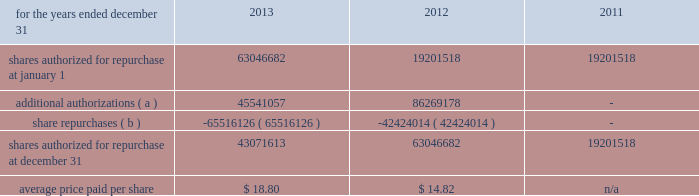Management 2019s discussion and analysis of financial condition and results of operations 82 fifth third bancorp to 100 million shares of its outstanding common stock in the open market or in privately negotiated transactions , and to utilize any derivative or similar instrument to affect share repurchase transactions .
This share repurchase authorization replaced the board 2019s previous authorization .
On may 21 , 2013 , the bancorp entered into an accelerated share repurchase transaction with a counterparty pursuant to which the bancorp purchased 25035519 shares , or approximately $ 539 million , of its outstanding common stock on may 24 , 2013 .
The bancorp repurchased the shares of its common stock as part of its 100 million share repurchase program previously announced on march 19 , 2013 .
At settlement of the forward contract on october 1 , 2013 , the bancorp received an additional 4270250 shares which were recorded as an adjustment to the basis in the treasury shares purchased on the acquisition date .
On november 13 , 2013 , the bancorp entered into an accelerated share repurchase transaction with a counterparty pursuant to which the bancorp purchased 8538423 shares , or approximately $ 200 million , of its outstanding common stock on november 18 , 2013 .
The bancorp repurchased the shares of its common stock as part of its board approved 100 million share repurchase program previously announced on march 19 , 2013 .
The bancorp expects the settlement of the transaction to occur on or before february 28 , 2014 .
On december 10 , 2013 , the bancorp entered into an accelerated share repurchase transaction with a counterparty pursuant to which the bancorp purchased 19084195 shares , or approximately $ 456 million , of its outstanding common stock on december 13 , 2013 .
The bancorp repurchased the shares of its common stock as part of its board approved 100 million share repurchase program previously announced on march 19 , 2013 .
The bancorp expects the settlement of the transaction to occur on or before march 26 , 2014 .
On january 28 , 2014 , the bancorp entered into an accelerated share repurchase transaction with a counterparty pursuant to which the bancorp purchased 3950705 shares , or approximately $ 99 million , of its outstanding common stock on january 31 , 2014 .
The bancorp repurchased the shares of its common stock as part of its board approved 100 million share repurchase program previously announced on march 19 , 2013 .
The bancorp expects the settlement of the transaction to occur on or before march 26 , 2014 .
Table 61 : share repurchases .
( a ) in march 2013 , the bancorp announced that its board of directors had authorized management to purchase 100 million shares of the bancorp 2019s common stock through the open market or in any private transaction .
The authorization does not include specific price targets or an expiration date .
This share repurchase authorization replaces the board 2019s previous authorization pursuant to which approximately 54 million shares remained available for repurchase by the bancorp .
( b ) excludes 1863097 , 2059003 and 1164254 shares repurchased during 2013 , 2012 , and 2011 , respectively , in connection with various employee compensation plans .
These repurchases are not included in the calculation for average price paid and do not count against the maximum number of shares that may yet be repurchased under the board of directors 2019 authorization .
Stress tests and ccar the frb issued guidelines known as ccar , which provide a common , conservative approach to ensure bhcs , including the bancorp , hold adequate capital to maintain ready access to funding , continue operations and meet their obligations to creditors and counterparties , and continue to serve as credit intermediaries , even in adverse conditions .
The ccar process requires the submission of a comprehensive capital plan that assumes a minimum planning horizon of nine quarters under various economic scenarios .
The mandatory elements of the capital plan are an assessment of the expected use and sources of capital over the planning horizon , a description of all planned capital actions over the planning horizon , a discussion of any expected changes to the bancorp 2019s business plan that are likely to have a material impact on its capital adequacy or liquidity , a detailed description of the bancorp 2019s process for assessing capital adequacy and the bancorp 2019s capital policy .
The capital plan must reflect the revised capital framework that the frb adopted in connection with the implementation of the basel iii accord , including the framework 2019s minimum regulatory capital ratios and transition arrangements .
The frb 2019s review of the capital plan will assess the comprehensiveness of the capital plan , the reasonableness of the assumptions and the analysis underlying the capital plan .
Additionally , the frb reviews the robustness of the capital adequacy process , the capital policy and the bancorp 2019s ability to maintain capital above the minimum regulatory capital ratios as they transition to basel iii and above a basel i tier 1 common ratio of 5 percent under baseline and stressful conditions throughout a nine- quarter planning horizon .
The frb issued stress testing rules that implement section 165 ( i ) ( 1 ) and ( i ) ( 2 ) of the dfa .
Large bhcs , including the bancorp , are subject to the final stress testing rules .
The rules require both supervisory and company-run stress tests , which provide forward- looking information to supervisors to help assess whether institutions have sufficient capital to absorb losses and support operations during adverse economic conditions .
In march of 2013 , the frb announced it had completed the 2013 ccar .
For bhcs that proposed capital distributions in their plan , the frb either objected to the plan or provided a non- objection whereby the frb concurred with the proposed 2013 capital distributions .
The frb indicated to the bancorp that it did not object to the following proposed capital actions for the period beginning april 1 , 2013 and ending march 31 , 2014 : f0b7 increase in the quarterly common stock dividend to $ 0.12 per share ; f0b7 repurchase of up to $ 750 million in trups subject to the determination of a regulatory capital event and replacement with the issuance of a similar amount of tier ii-qualifying subordinated debt ; f0b7 conversion of the $ 398 million in outstanding series g 8.5% ( 8.5 % ) convertible preferred stock into approximately 35.5 million common shares issued to the holders .
If this conversion were to occur , the bancorp would intend to repurchase common shares equivalent to those issued in the conversion up to $ 550 million in market value , and issue $ 550 million in preferred stock; .
What is the total cash outflow spent for shares repurchased during 2013 , in millions? 
Computations: ((18.80 * 43071613) / 1000000)
Answer: 809.74632. 